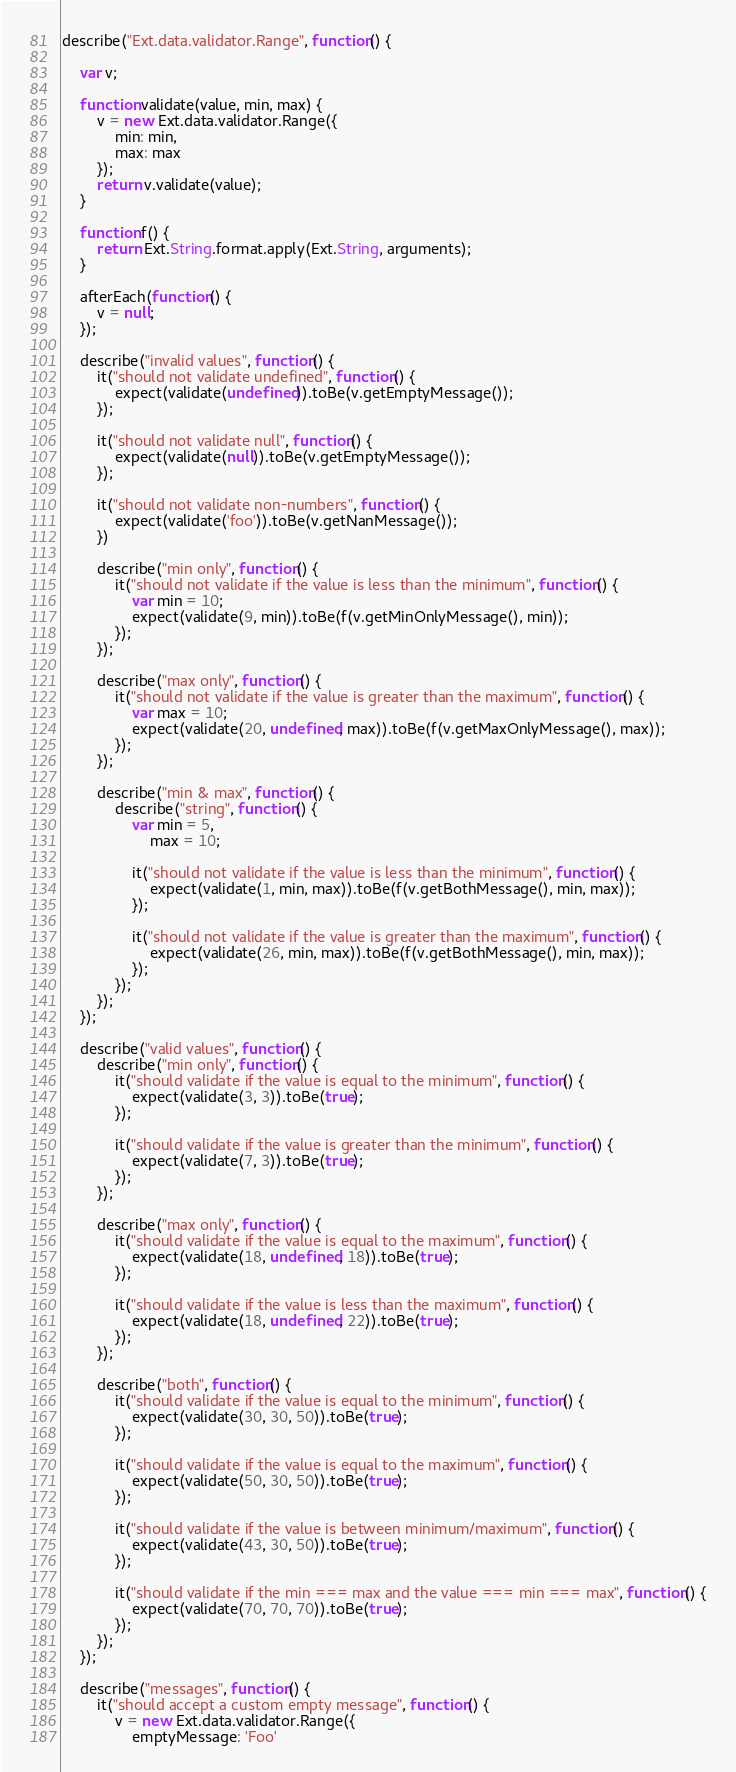Convert code to text. <code><loc_0><loc_0><loc_500><loc_500><_JavaScript_>describe("Ext.data.validator.Range", function() {
    
    var v;
    
    function validate(value, min, max) {
        v = new Ext.data.validator.Range({
            min: min,
            max: max
        });
        return v.validate(value);
    }
    
    function f() {
        return Ext.String.format.apply(Ext.String, arguments);
    }
    
    afterEach(function() {
        v = null;
    });
    
    describe("invalid values", function() {
        it("should not validate undefined", function() {
            expect(validate(undefined)).toBe(v.getEmptyMessage());    
        });
        
        it("should not validate null", function() {
            expect(validate(null)).toBe(v.getEmptyMessage());    
        });

        it("should not validate non-numbers", function() {
            expect(validate('foo')).toBe(v.getNanMessage());
        })
        
        describe("min only", function() {
            it("should not validate if the value is less than the minimum", function() {
                var min = 10;
                expect(validate(9, min)).toBe(f(v.getMinOnlyMessage(), min));    
            });
        });
        
        describe("max only", function() {
            it("should not validate if the value is greater than the maximum", function() {
                var max = 10;
                expect(validate(20, undefined, max)).toBe(f(v.getMaxOnlyMessage(), max));
            });    
        });
        
        describe("min & max", function() {  
            describe("string", function() {
                var min = 5, 
                    max = 10;
                    
                it("should not validate if the value is less than the minimum", function() {
                    expect(validate(1, min, max)).toBe(f(v.getBothMessage(), min, max));    
                });
            
                it("should not validate if the value is greater than the maximum", function() {
                    expect(validate(26, min, max)).toBe(f(v.getBothMessage(), min, max));    
                });
            });
        });
    });
    
    describe("valid values", function() {
        describe("min only", function() {
            it("should validate if the value is equal to the minimum", function() {
                expect(validate(3, 3)).toBe(true);
            });  
        
            it("should validate if the value is greater than the minimum", function() {
                expect(validate(7, 3)).toBe(true);
            });
        });
        
        describe("max only", function() {
            it("should validate if the value is equal to the maximum", function() {
                expect(validate(18, undefined, 18)).toBe(true);
            });  
        
            it("should validate if the value is less than the maximum", function() {
                expect(validate(18, undefined, 22)).toBe(true);
            });
        });
        
        describe("both", function() {
            it("should validate if the value is equal to the minimum", function() {
                expect(validate(30, 30, 50)).toBe(true);
            });
            
            it("should validate if the value is equal to the maximum", function() {
                expect(validate(50, 30, 50)).toBe(true);
            });
            
            it("should validate if the value is between minimum/maximum", function() {
                expect(validate(43, 30, 50)).toBe(true);
            });
            
            it("should validate if the min === max and the value === min === max", function() {
                expect(validate(70, 70, 70)).toBe(true);
            });
        });
    });
    
    describe("messages", function() {
        it("should accept a custom empty message", function() {
            v = new Ext.data.validator.Range({
                emptyMessage: 'Foo'</code> 